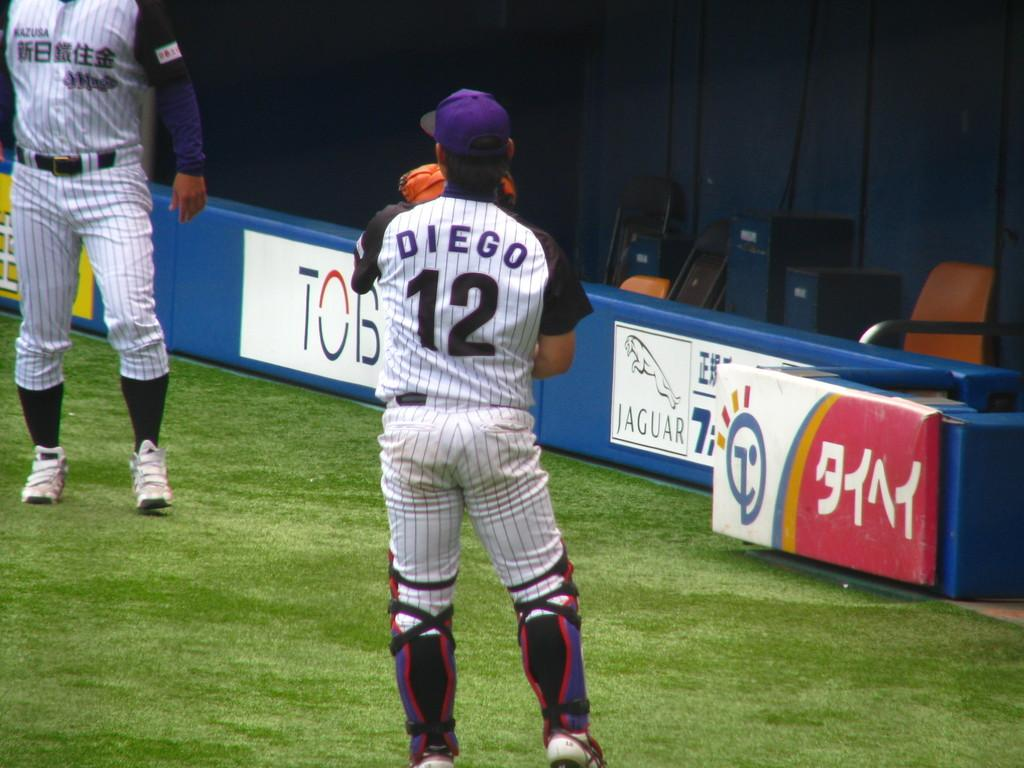Provide a one-sentence caption for the provided image. A player named Diego wearing jersey number 12. 